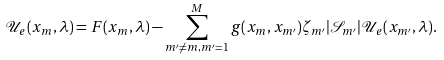<formula> <loc_0><loc_0><loc_500><loc_500>\mathcal { U } _ { e } ( x _ { m } , \lambda ) = F ( x _ { m } , \lambda ) - \sum ^ { M } _ { m ^ { \prime } \neq m , m ^ { \prime } = 1 } g ( x _ { m } , x _ { m ^ { \prime } } ) \zeta _ { m ^ { \prime } } | \mathcal { S } _ { m ^ { \prime } } | \mathcal { U } _ { e } ( x _ { m ^ { \prime } } , \lambda ) .</formula> 